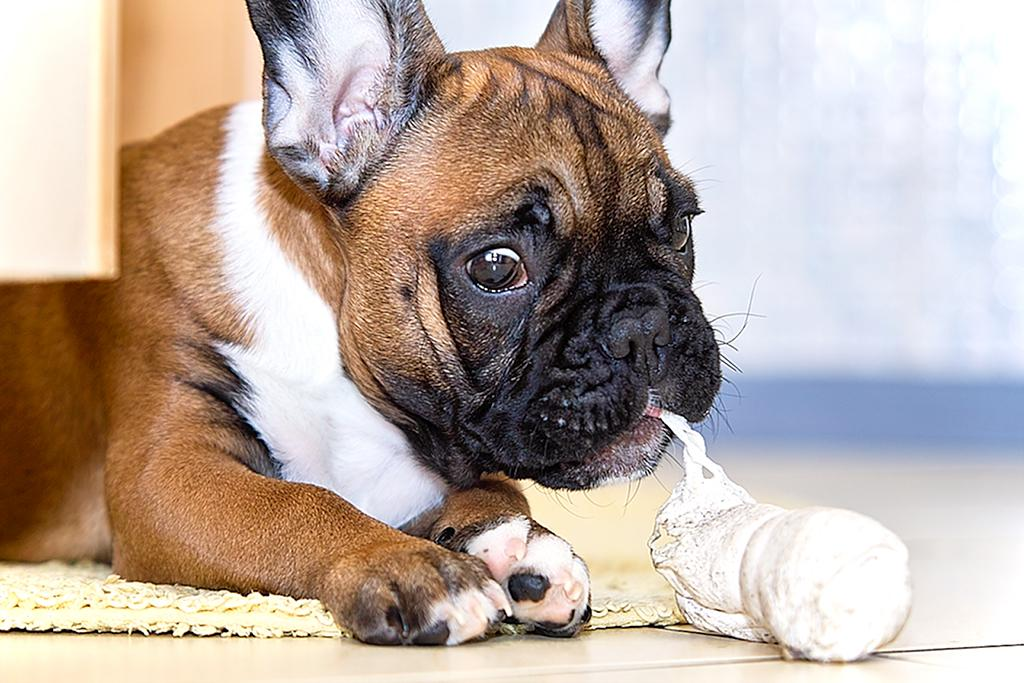What animal is present in the image? There is a dog in the image. Where is the dog located in the image? The dog is sitting on a mat on the floor. What is the dog holding in its mouth? There is an object at the dog's mouth. Can you describe the background of the image? The background of the image is blurry. What shape is the toothbrush in the image? There is no toothbrush present in the image. What song is the dog singing in the image? Dogs do not sing songs, and there is no indication of any song in the image. 